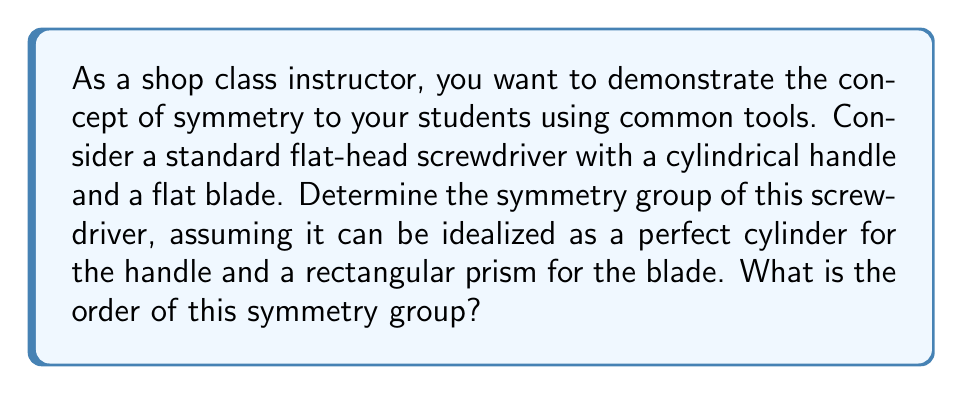Teach me how to tackle this problem. To solve this problem, we need to consider the symmetries of the screwdriver:

1) First, let's consider the handle:
   - It has rotational symmetry around its central axis (infinite rotations).
   - It has reflection symmetry across any plane containing its central axis.

2) Now, let's consider the blade:
   - It has 2-fold rotational symmetry around its central axis.
   - It has 2 reflection symmetries: one across the plane parallel to the flat side, and one across the plane perpendicular to the flat side.

3) The symmetry group of the entire screwdriver is the intersection of these symmetries:
   - It retains the 2-fold rotational symmetry around the central axis.
   - It retains 2 reflection symmetries: one across the plane of the blade, and one perpendicular to it.

4) This symmetry group is isomorphic to the dihedral group $D_2$, also known as the Klein four-group.

5) The elements of this group are:
   - The identity transformation (e)
   - Rotation by 180° around the central axis (r)
   - Reflection across the plane of the blade (s)
   - Reflection across the plane perpendicular to the blade (t)

6) We can represent this group using the following Cayley table:

   $$\begin{array}{c|cccc}
     & e & r & s & t \\
   \hline
   e & e & r & s & t \\
   r & r & e & t & s \\
   s & s & t & e & r \\
   t & t & s & r & e
   \end{array}$$

7) The order of a group is the number of elements in the group. In this case, there are 4 elements.

Therefore, the symmetry group of the screwdriver is isomorphic to $D_2$, and its order is 4.
Answer: The symmetry group of the idealized screwdriver is isomorphic to $D_2$ (the dihedral group of order 4), and the order of this group is 4. 